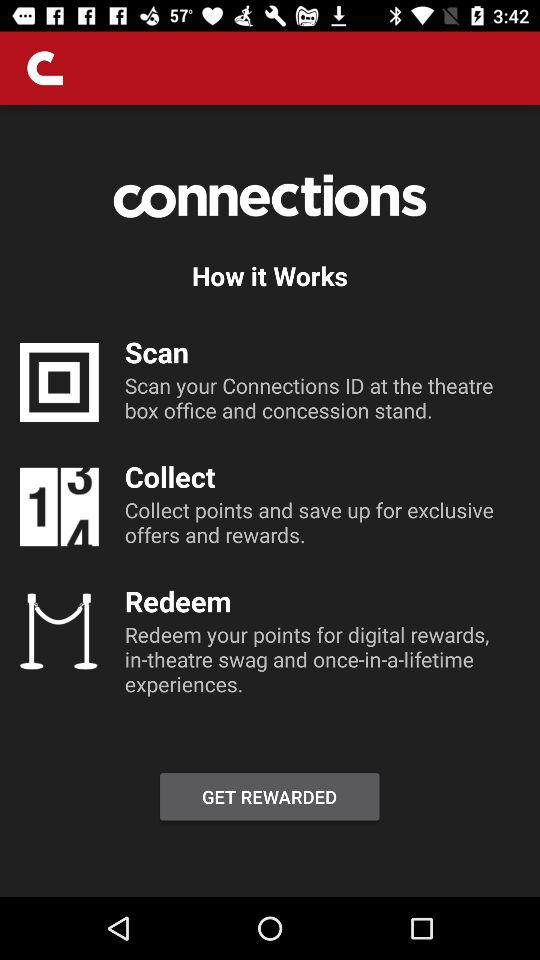How many steps are there in the How it Works section?
Answer the question using a single word or phrase. 3 